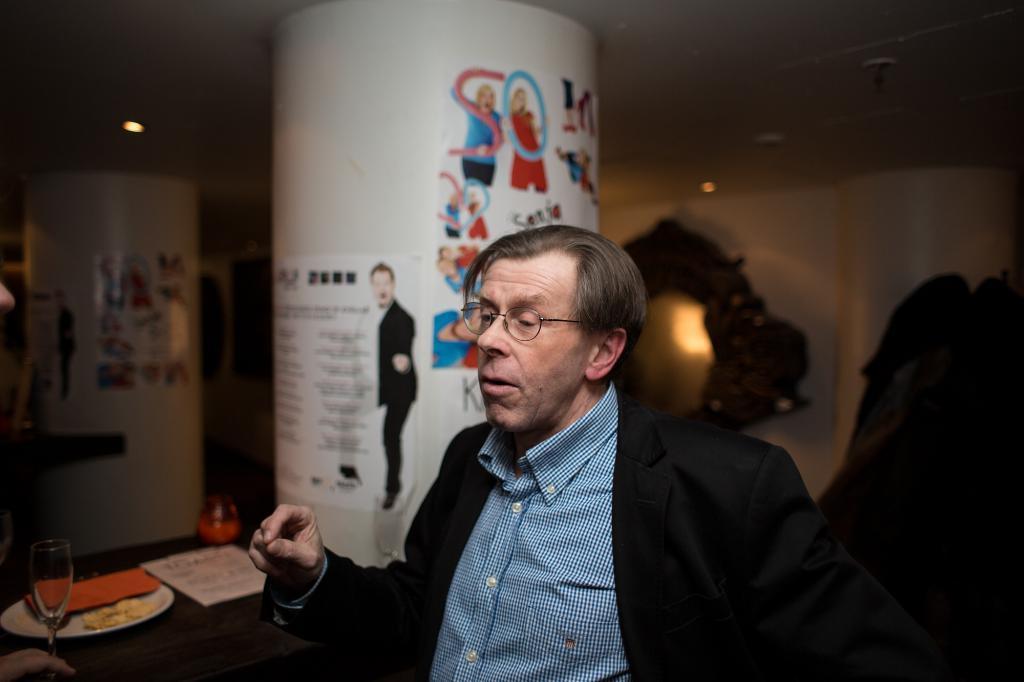In one or two sentences, can you explain what this image depicts? In this image I can see a man is sitting on a chair in front of a table. On the table I can see there are few objects. 